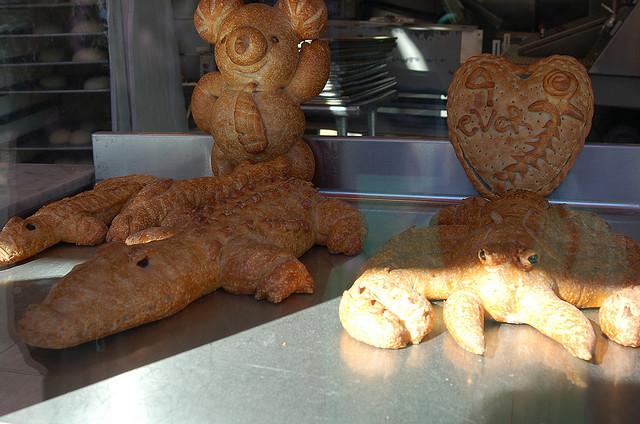Is there anything edible in this photo?
Give a very brief answer. Yes. What are these creations made of?
Write a very short answer. Bread. What does the heart say?
Short answer required. 4 ever. 